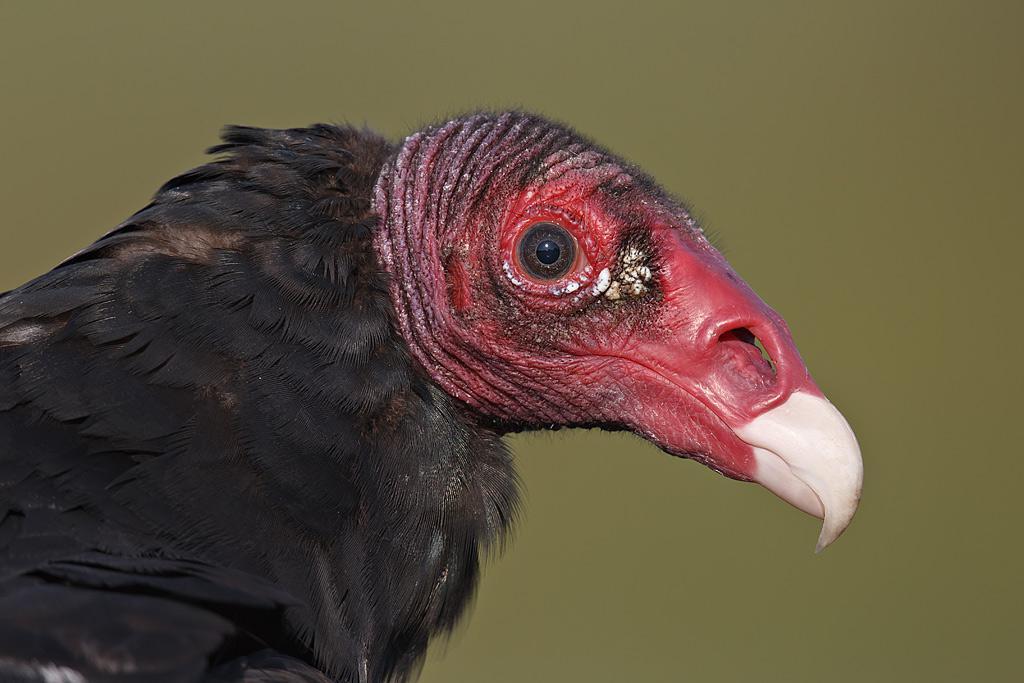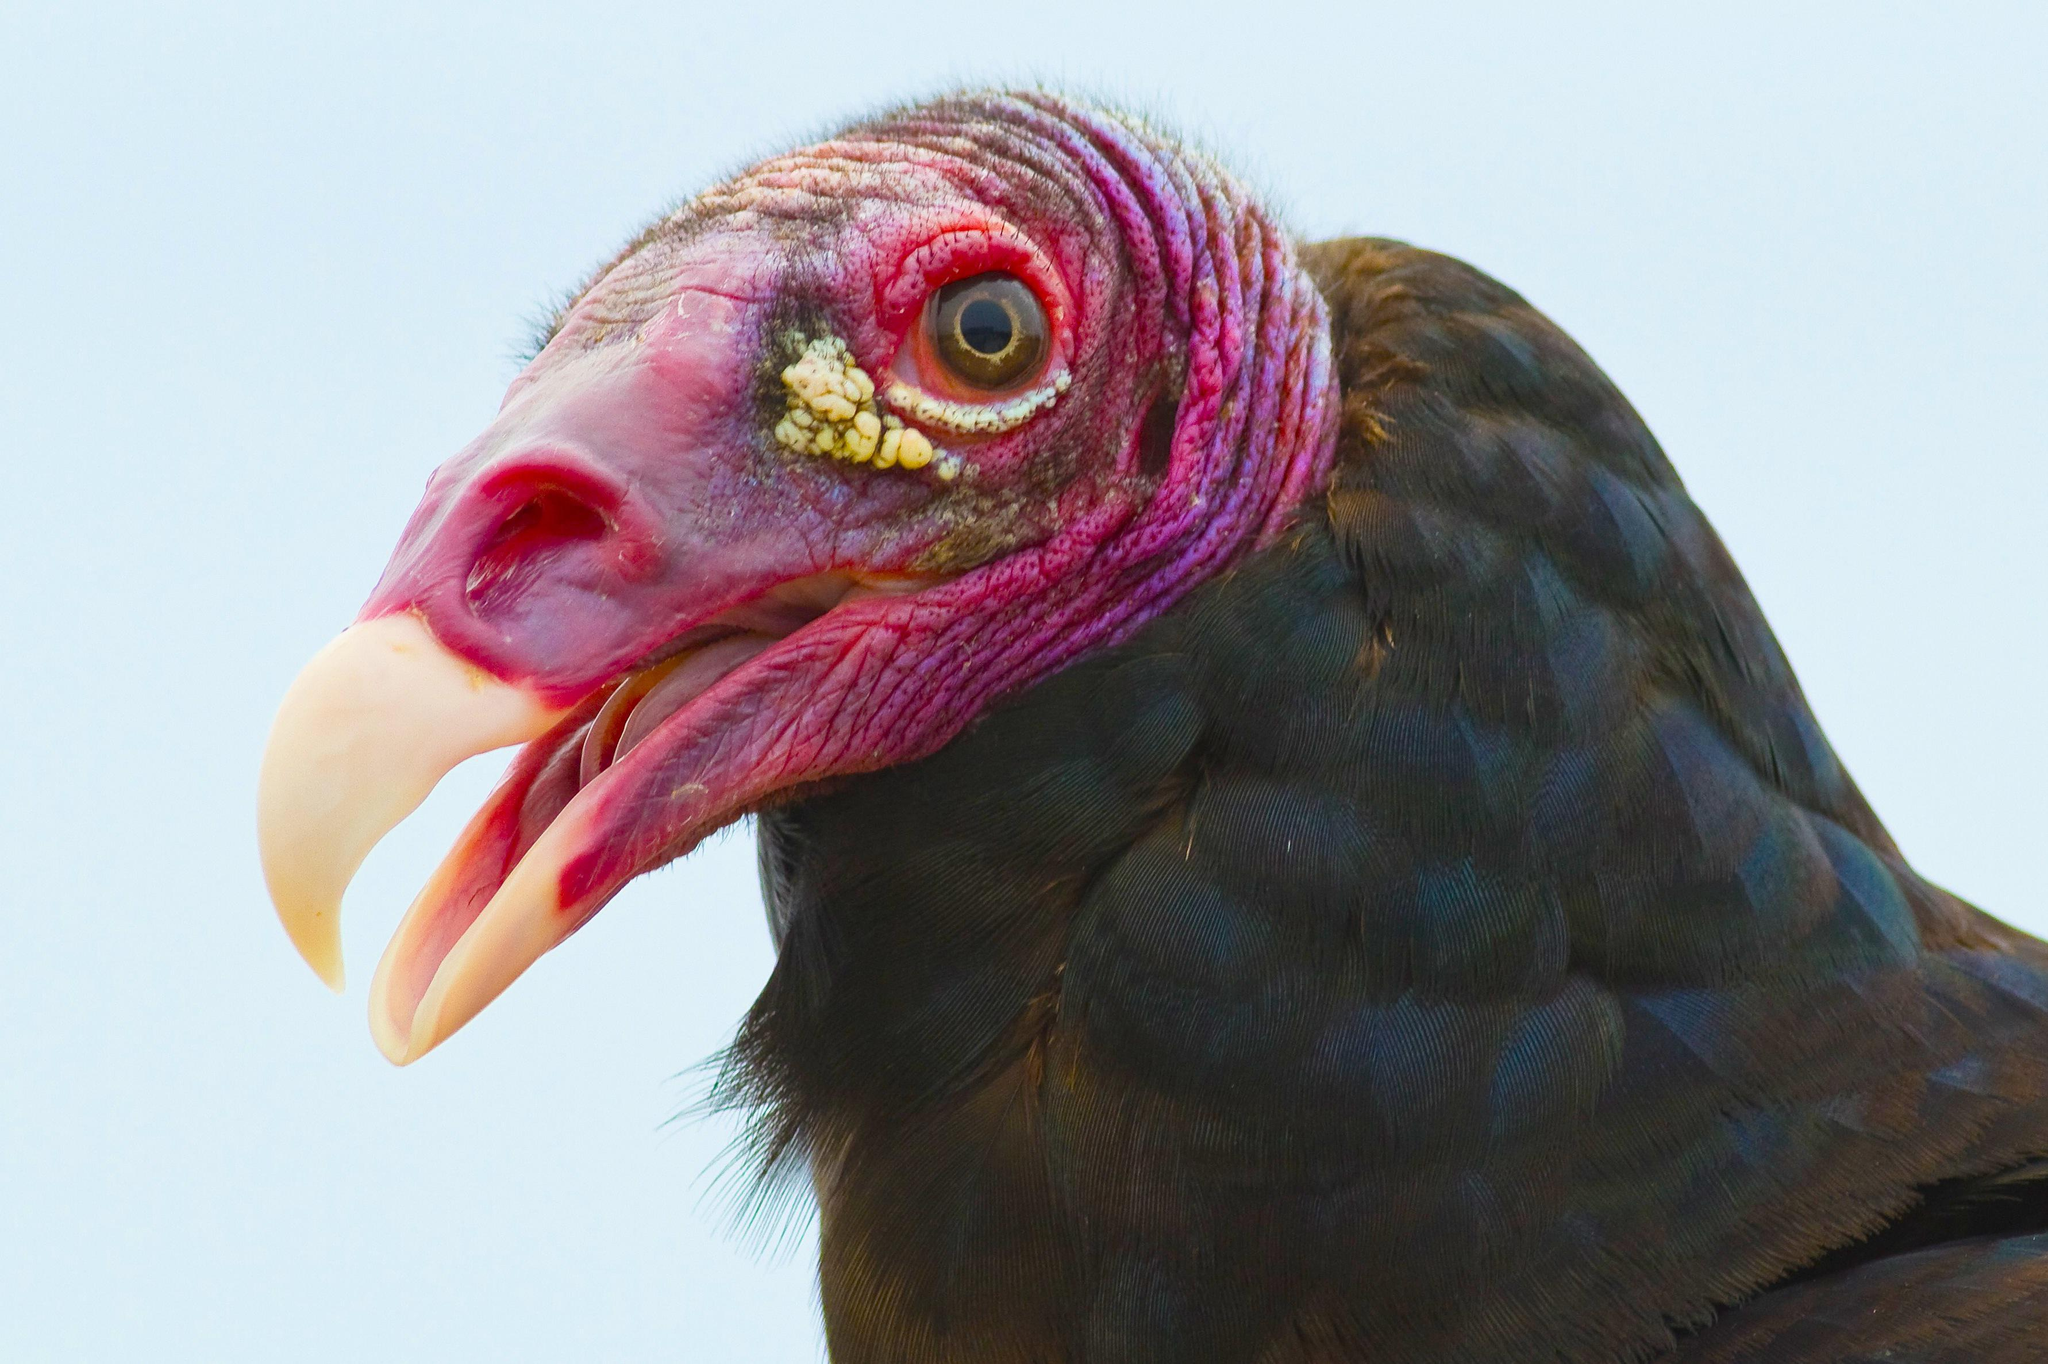The first image is the image on the left, the second image is the image on the right. Analyze the images presented: Is the assertion "An image shows a vulture standing on a kind of perch." valid? Answer yes or no. No. 